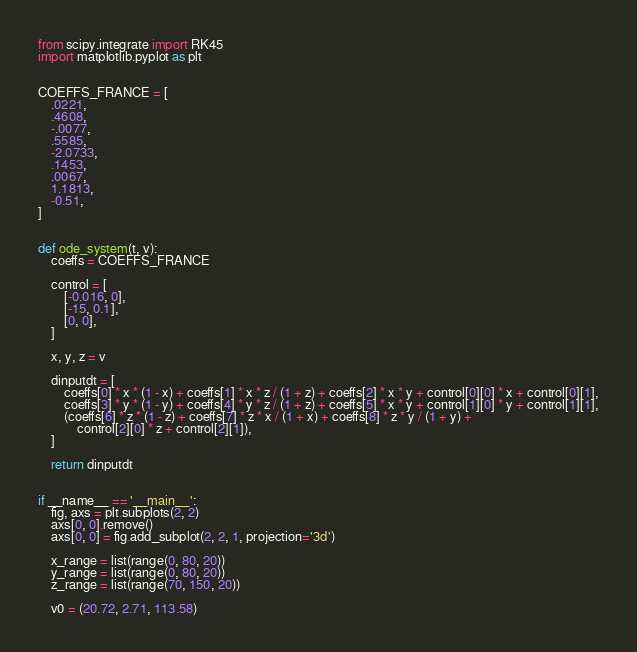Convert code to text. <code><loc_0><loc_0><loc_500><loc_500><_Python_>from scipy.integrate import RK45
import matplotlib.pyplot as plt


COEFFS_FRANCE = [
    .0221,
    .4608,
    -.0077,
    .5585,
    -2.0733,
    .1453,
    .0067,
    1.1813,
    -0.51,
]


def ode_system(t, v):
    coeffs = COEFFS_FRANCE

    control = [
        [-0.016, 0],
        [-15, 0.1],
        [0, 0],
    ]

    x, y, z = v

    dinputdt = [
        coeffs[0] * x * (1 - x) + coeffs[1] * x * z / (1 + z) + coeffs[2] * x * y + control[0][0] * x + control[0][1],
        coeffs[3] * y * (1 - y) + coeffs[4] * y * z / (1 + z) + coeffs[5] * x * y + control[1][0] * y + control[1][1],
        (coeffs[6] * z * (1 - z) + coeffs[7] * z * x / (1 + x) + coeffs[8] * z * y / (1 + y) +
            control[2][0] * z + control[2][1]),
    ]

    return dinputdt


if __name__ == '__main__':
    fig, axs = plt.subplots(2, 2)
    axs[0, 0].remove()
    axs[0, 0] = fig.add_subplot(2, 2, 1, projection='3d')

    x_range = list(range(0, 80, 20))
    y_range = list(range(0, 80, 20))
    z_range = list(range(70, 150, 20))

    v0 = (20.72, 2.71, 113.58)
</code> 